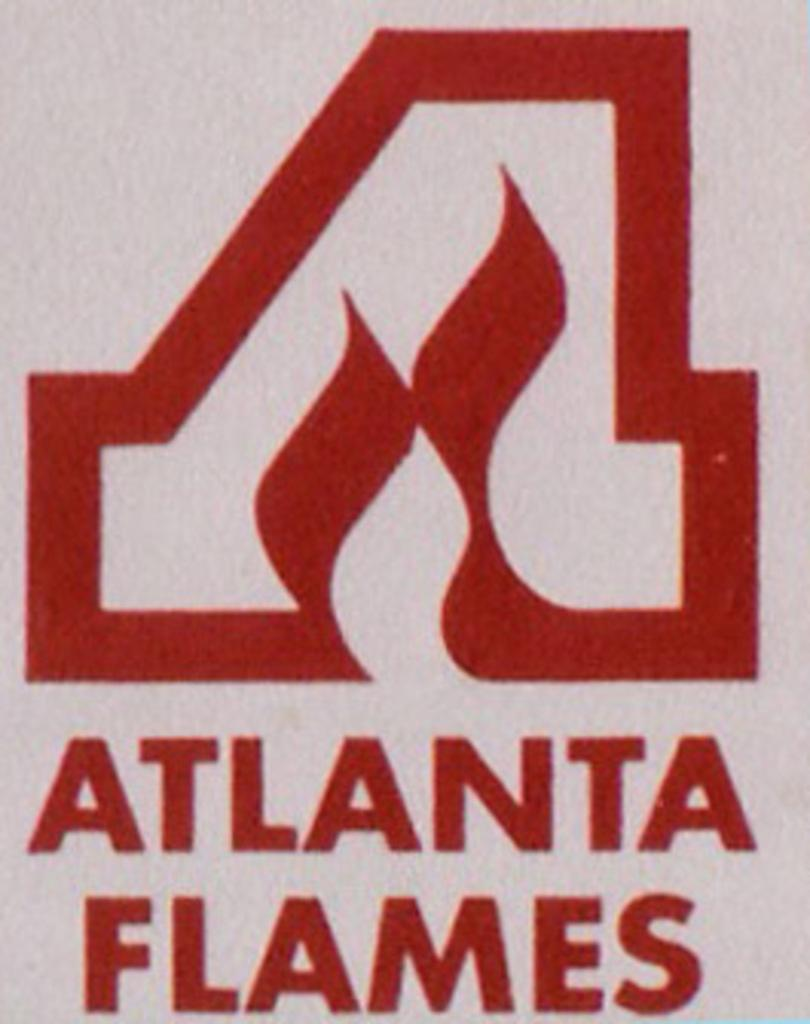<image>
Create a compact narrative representing the image presented. A stylized letter A above the words Atlanta Flames. 